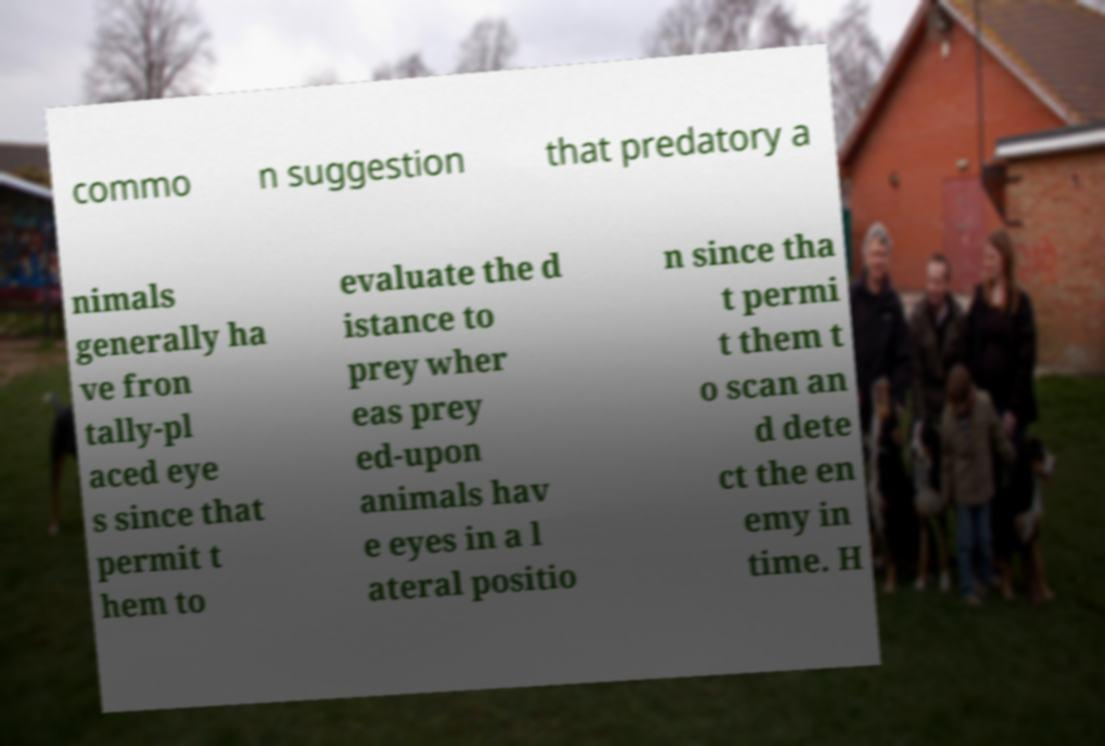Please identify and transcribe the text found in this image. commo n suggestion that predatory a nimals generally ha ve fron tally-pl aced eye s since that permit t hem to evaluate the d istance to prey wher eas prey ed-upon animals hav e eyes in a l ateral positio n since tha t permi t them t o scan an d dete ct the en emy in time. H 